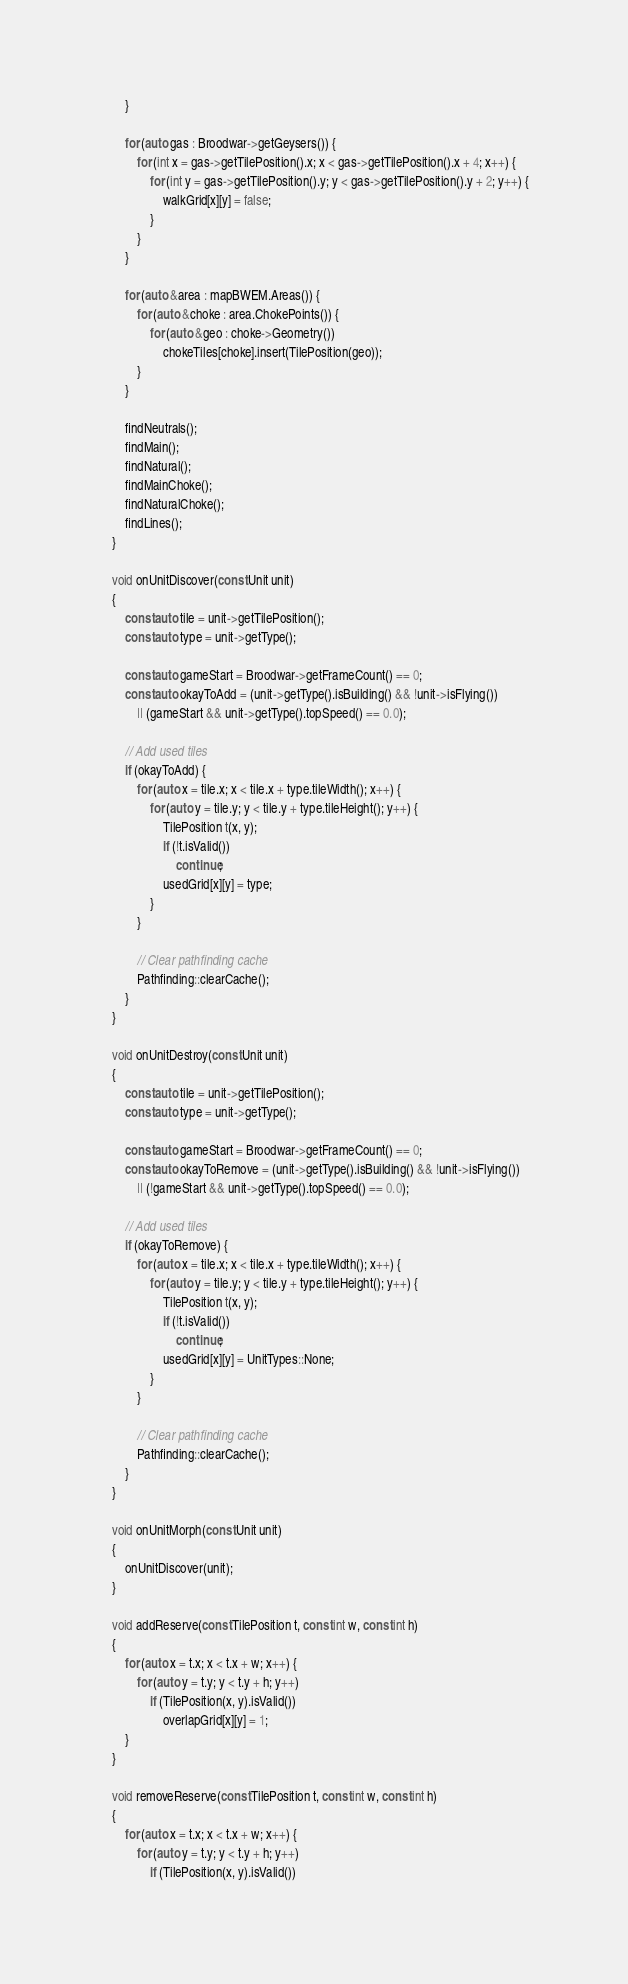<code> <loc_0><loc_0><loc_500><loc_500><_C++_>        }

        for (auto gas : Broodwar->getGeysers()) {
            for (int x = gas->getTilePosition().x; x < gas->getTilePosition().x + 4; x++) {
                for (int y = gas->getTilePosition().y; y < gas->getTilePosition().y + 2; y++) {
                    walkGrid[x][y] = false;
                }
            }
        }

        for (auto &area : mapBWEM.Areas()) {
            for (auto &choke : area.ChokePoints()) {
                for (auto &geo : choke->Geometry())
                    chokeTiles[choke].insert(TilePosition(geo));
            }
        }

        findNeutrals();
        findMain();
        findNatural();
        findMainChoke();
        findNaturalChoke();
        findLines();
    }

    void onUnitDiscover(const Unit unit)
    {
        const auto tile = unit->getTilePosition();
        const auto type = unit->getType();

        const auto gameStart = Broodwar->getFrameCount() == 0;
        const auto okayToAdd = (unit->getType().isBuilding() && !unit->isFlying())
            || (gameStart && unit->getType().topSpeed() == 0.0);

        // Add used tiles
        if (okayToAdd) {
            for (auto x = tile.x; x < tile.x + type.tileWidth(); x++) {
                for (auto y = tile.y; y < tile.y + type.tileHeight(); y++) {
                    TilePosition t(x, y);
                    if (!t.isValid())
                        continue;
                    usedGrid[x][y] = type;
                }
            }

            // Clear pathfinding cache
            Pathfinding::clearCache();
        }
    }

    void onUnitDestroy(const Unit unit)
    {
        const auto tile = unit->getTilePosition();
        const auto type = unit->getType();

        const auto gameStart = Broodwar->getFrameCount() == 0;
        const auto okayToRemove = (unit->getType().isBuilding() && !unit->isFlying())
            || (!gameStart && unit->getType().topSpeed() == 0.0);

        // Add used tiles
        if (okayToRemove) {
            for (auto x = tile.x; x < tile.x + type.tileWidth(); x++) {
                for (auto y = tile.y; y < tile.y + type.tileHeight(); y++) {
                    TilePosition t(x, y);
                    if (!t.isValid())
                        continue;
                    usedGrid[x][y] = UnitTypes::None;
                }
            }

            // Clear pathfinding cache
            Pathfinding::clearCache();
        }
    }

    void onUnitMorph(const Unit unit)
    {
        onUnitDiscover(unit);
    }

    void addReserve(const TilePosition t, const int w, const int h)
    {
        for (auto x = t.x; x < t.x + w; x++) {
            for (auto y = t.y; y < t.y + h; y++)
                if (TilePosition(x, y).isValid())
                    overlapGrid[x][y] = 1;
        }
    }

    void removeReserve(const TilePosition t, const int w, const int h)
    {
        for (auto x = t.x; x < t.x + w; x++) {
            for (auto y = t.y; y < t.y + h; y++)
                if (TilePosition(x, y).isValid())</code> 